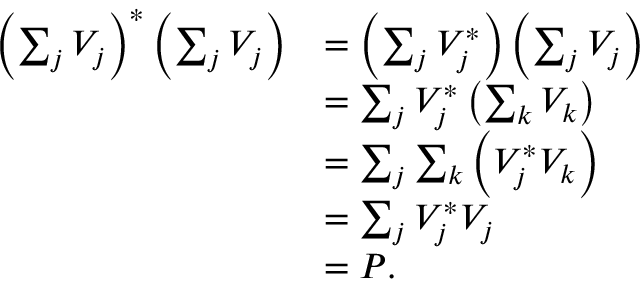Convert formula to latex. <formula><loc_0><loc_0><loc_500><loc_500>\begin{array} { r l } { \left ( \sum _ { j } V _ { j } \right ) ^ { * } \left ( \sum _ { j } V _ { j } \right ) } & { = \left ( \sum _ { j } V _ { j } ^ { * } \right ) \left ( \sum _ { j } V _ { j } \right ) } \\ & { = \sum _ { j } V _ { j } ^ { * } \left ( \sum _ { k } V _ { k } \right ) } \\ & { = \sum _ { j } \sum _ { k } \left ( V _ { j } ^ { * } V _ { k } \right ) } \\ & { = \sum _ { j } V _ { j } ^ { * } V _ { j } } \\ & { = P . } \end{array}</formula> 